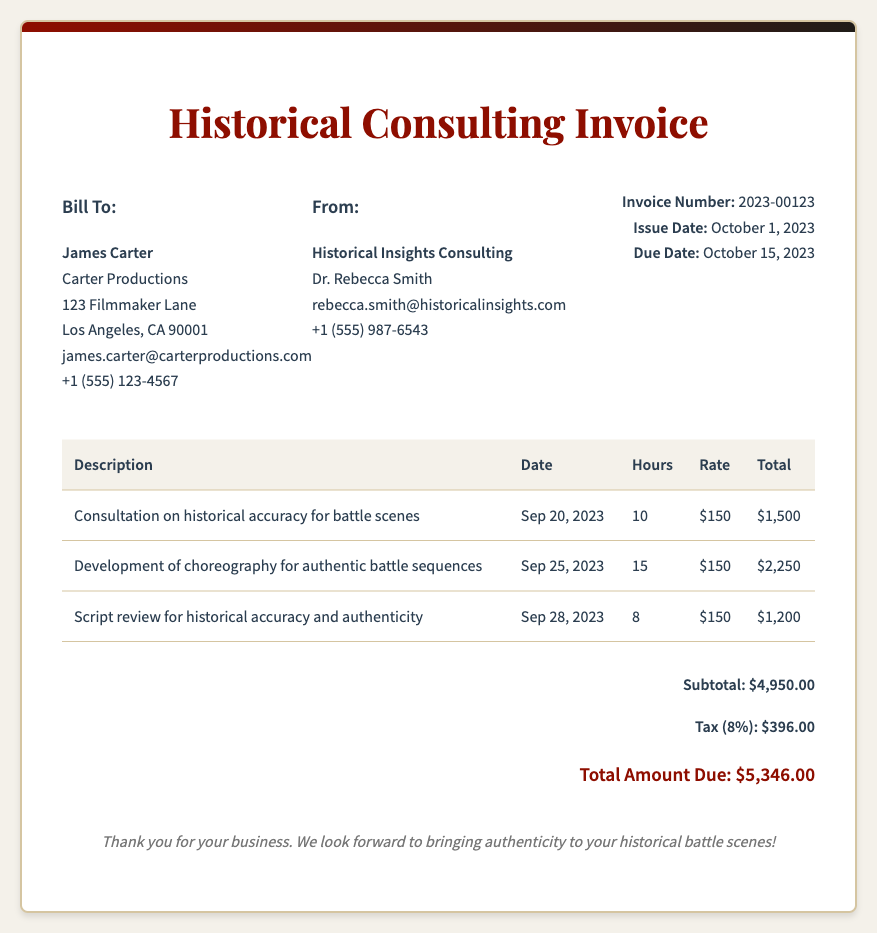What is the invoice number? The invoice number is listed in the invoice details section, which is 2023-00123.
Answer: 2023-00123 Who is the client? The client's name appears in the bill to section, which is James Carter.
Answer: James Carter What is the total amount due? The total amount due is stated in the total section at the bottom of the invoice, which is $5,346.00.
Answer: $5,346.00 How many hours were billed for the development of choreography? The hours for this service are provided in the table under the hours column, which is 15.
Answer: 15 What date was the consultation on historical accuracy? The date for this service is mentioned in the table, which is September 20, 2023.
Answer: Sep 20, 2023 What is the tax rate applied in this invoice? The tax percentage is indicated in the total section, which is 8%.
Answer: 8% Who is the contact person for Historical Insights Consulting? The consultant's name is listed under the "From" section, which is Dr. Rebecca Smith.
Answer: Dr. Rebecca Smith What is the subtotal before tax? The subtotal is found in the total section, which is $4,950.00.
Answer: $4,950.00 What type of services were provided in this invoice? The services provided are detailed in the table describing consultations, choreography development, and script review.
Answer: Consultation, choreography development, script review 